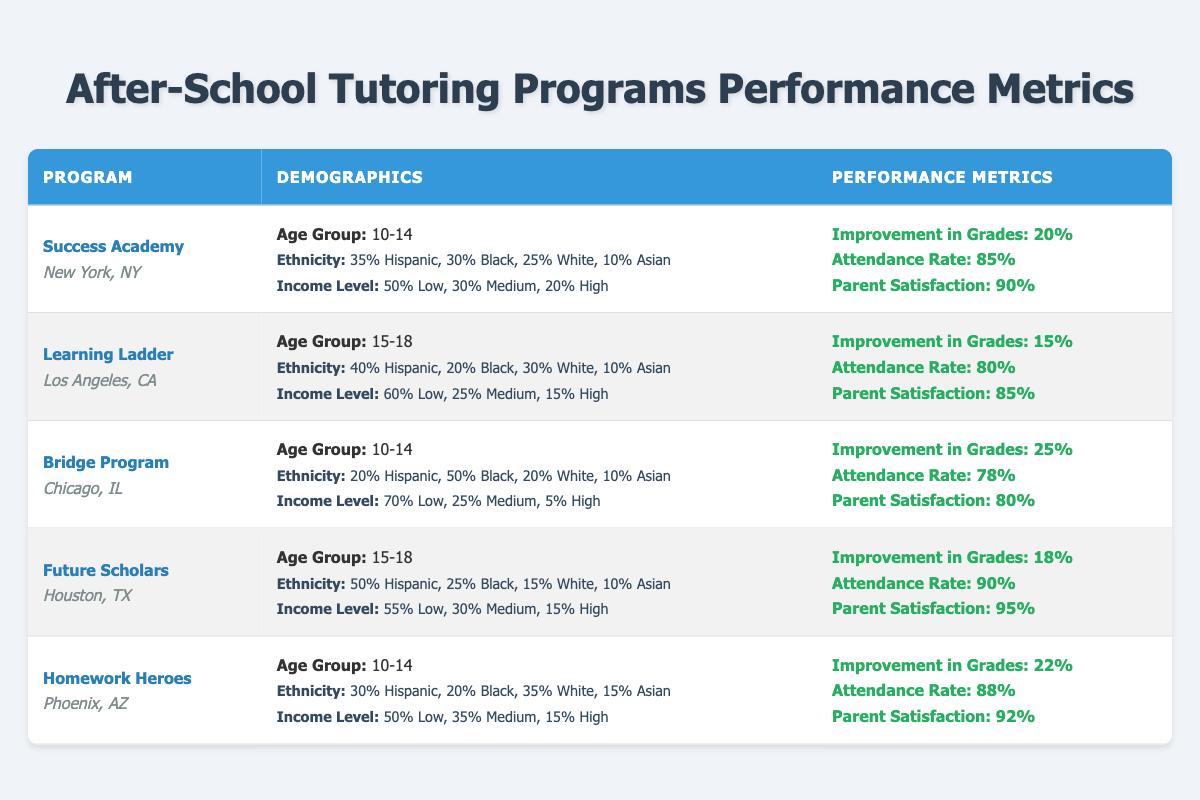What is the attendance rate of the Success Academy? The table shows the attendance rate for Success Academy as 85%.
Answer: 85% Which program has the highest parent satisfaction? The table indicates that Future Scholars has the highest parent satisfaction at 95%.
Answer: 95% What percentage of students at the Bridge Program are Black? In the Bridge Program, 50% of the students are Black, as per the demographic data.
Answer: 50% What is the improvement in grades for the Homework Heroes program? According to the table, Homework Heroes has an improvement in grades of 22%.
Answer: 22% Which age group is served by the Learning Ladder? The table states that Learning Ladder serves the age group of 15-18.
Answer: 15-18 What is the average improvement in grades for the programs serving ages 10-14? The improvement in grades for the programs in this age group are: Success Academy (20%), Bridge Program (25%), and Homework Heroes (22%). Summing these gives 67%, dividing by 3 gives an average of 22.33%.
Answer: 22.33% Is the income level of the majority of students in the Future Scholars program classified as High? The data shows that 55% of students are classified as Low, and only 15% as High, so most are not in the High income level.
Answer: No Which program has the lowest attendance rate? The Bridge Program has the lowest attendance rate listed at 78%.
Answer: 78% If a program has a parent satisfaction of 90%, what is its name? The table indicates that both Success Academy and Homework Heroes have a parent satisfaction of 90% or above, specifically listing Success Academy at 90% and Homework Heroes at 92%.
Answer: Success Academy, Homework Heroes What is the total percentage of Hispanic students across all programs? The percentages of Hispanic students are: Success Academy (35%), Learning Ladder (40%), Bridge Program (20%), Future Scholars (50%), and Homework Heroes (30%). Adding these up gives a total of 175%.
Answer: 175% 